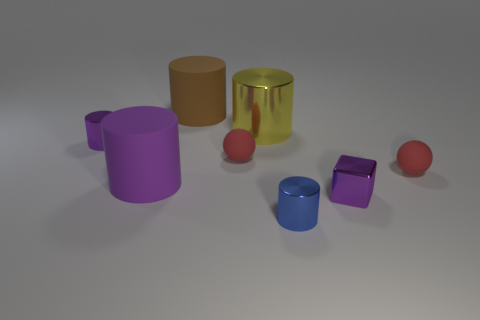Subtract 1 cylinders. How many cylinders are left? 4 Subtract all blue cylinders. How many cylinders are left? 4 Subtract all big yellow cylinders. How many cylinders are left? 4 Subtract all cyan cylinders. Subtract all yellow cubes. How many cylinders are left? 5 Add 1 large yellow metallic objects. How many objects exist? 9 Subtract all cubes. How many objects are left? 7 Add 5 big yellow objects. How many big yellow objects are left? 6 Add 4 tiny matte cubes. How many tiny matte cubes exist? 4 Subtract 0 green balls. How many objects are left? 8 Subtract all small purple metal cubes. Subtract all small cubes. How many objects are left? 6 